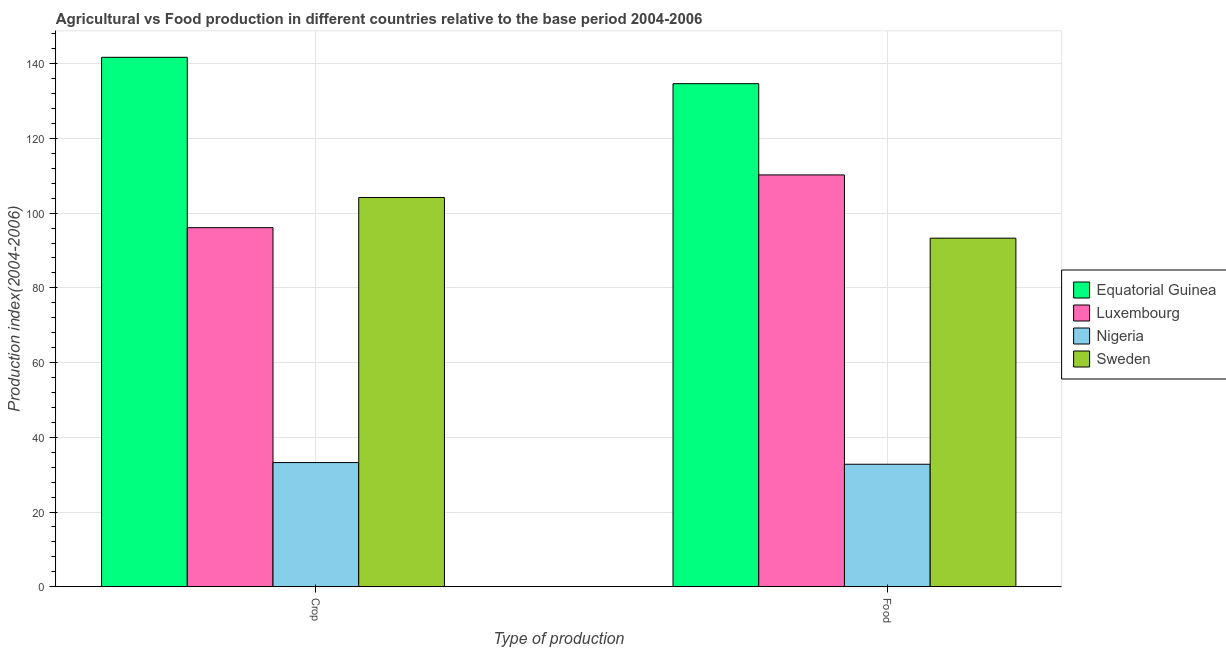Are the number of bars per tick equal to the number of legend labels?
Your response must be concise. Yes. Are the number of bars on each tick of the X-axis equal?
Provide a short and direct response. Yes. How many bars are there on the 2nd tick from the left?
Ensure brevity in your answer.  4. What is the label of the 1st group of bars from the left?
Provide a succinct answer. Crop. What is the crop production index in Sweden?
Your answer should be compact. 104.19. Across all countries, what is the maximum crop production index?
Keep it short and to the point. 141.71. Across all countries, what is the minimum food production index?
Your answer should be compact. 32.79. In which country was the food production index maximum?
Offer a very short reply. Equatorial Guinea. In which country was the crop production index minimum?
Offer a very short reply. Nigeria. What is the total crop production index in the graph?
Ensure brevity in your answer.  375.25. What is the difference between the crop production index in Luxembourg and that in Equatorial Guinea?
Provide a short and direct response. -45.6. What is the difference between the food production index in Luxembourg and the crop production index in Sweden?
Offer a very short reply. 6.04. What is the average food production index per country?
Keep it short and to the point. 92.74. What is the difference between the crop production index and food production index in Luxembourg?
Give a very brief answer. -14.12. What is the ratio of the food production index in Sweden to that in Nigeria?
Ensure brevity in your answer.  2.85. In how many countries, is the crop production index greater than the average crop production index taken over all countries?
Offer a terse response. 3. What does the 3rd bar from the left in Crop represents?
Ensure brevity in your answer.  Nigeria. What does the 2nd bar from the right in Food represents?
Give a very brief answer. Nigeria. Are all the bars in the graph horizontal?
Offer a terse response. No. How many countries are there in the graph?
Ensure brevity in your answer.  4. Does the graph contain any zero values?
Keep it short and to the point. No. How are the legend labels stacked?
Provide a short and direct response. Vertical. What is the title of the graph?
Provide a short and direct response. Agricultural vs Food production in different countries relative to the base period 2004-2006. Does "Congo (Democratic)" appear as one of the legend labels in the graph?
Keep it short and to the point. No. What is the label or title of the X-axis?
Your response must be concise. Type of production. What is the label or title of the Y-axis?
Make the answer very short. Production index(2004-2006). What is the Production index(2004-2006) of Equatorial Guinea in Crop?
Provide a succinct answer. 141.71. What is the Production index(2004-2006) in Luxembourg in Crop?
Offer a very short reply. 96.11. What is the Production index(2004-2006) of Nigeria in Crop?
Offer a very short reply. 33.24. What is the Production index(2004-2006) in Sweden in Crop?
Offer a terse response. 104.19. What is the Production index(2004-2006) of Equatorial Guinea in Food?
Offer a terse response. 134.65. What is the Production index(2004-2006) of Luxembourg in Food?
Your response must be concise. 110.23. What is the Production index(2004-2006) in Nigeria in Food?
Make the answer very short. 32.79. What is the Production index(2004-2006) of Sweden in Food?
Offer a very short reply. 93.3. Across all Type of production, what is the maximum Production index(2004-2006) in Equatorial Guinea?
Keep it short and to the point. 141.71. Across all Type of production, what is the maximum Production index(2004-2006) of Luxembourg?
Offer a very short reply. 110.23. Across all Type of production, what is the maximum Production index(2004-2006) in Nigeria?
Your answer should be compact. 33.24. Across all Type of production, what is the maximum Production index(2004-2006) of Sweden?
Offer a very short reply. 104.19. Across all Type of production, what is the minimum Production index(2004-2006) in Equatorial Guinea?
Give a very brief answer. 134.65. Across all Type of production, what is the minimum Production index(2004-2006) of Luxembourg?
Give a very brief answer. 96.11. Across all Type of production, what is the minimum Production index(2004-2006) in Nigeria?
Make the answer very short. 32.79. Across all Type of production, what is the minimum Production index(2004-2006) of Sweden?
Make the answer very short. 93.3. What is the total Production index(2004-2006) of Equatorial Guinea in the graph?
Give a very brief answer. 276.36. What is the total Production index(2004-2006) in Luxembourg in the graph?
Make the answer very short. 206.34. What is the total Production index(2004-2006) of Nigeria in the graph?
Make the answer very short. 66.03. What is the total Production index(2004-2006) in Sweden in the graph?
Offer a very short reply. 197.49. What is the difference between the Production index(2004-2006) in Equatorial Guinea in Crop and that in Food?
Keep it short and to the point. 7.06. What is the difference between the Production index(2004-2006) in Luxembourg in Crop and that in Food?
Offer a very short reply. -14.12. What is the difference between the Production index(2004-2006) of Nigeria in Crop and that in Food?
Make the answer very short. 0.45. What is the difference between the Production index(2004-2006) in Sweden in Crop and that in Food?
Keep it short and to the point. 10.89. What is the difference between the Production index(2004-2006) of Equatorial Guinea in Crop and the Production index(2004-2006) of Luxembourg in Food?
Offer a terse response. 31.48. What is the difference between the Production index(2004-2006) of Equatorial Guinea in Crop and the Production index(2004-2006) of Nigeria in Food?
Offer a very short reply. 108.92. What is the difference between the Production index(2004-2006) of Equatorial Guinea in Crop and the Production index(2004-2006) of Sweden in Food?
Offer a terse response. 48.41. What is the difference between the Production index(2004-2006) in Luxembourg in Crop and the Production index(2004-2006) in Nigeria in Food?
Give a very brief answer. 63.32. What is the difference between the Production index(2004-2006) in Luxembourg in Crop and the Production index(2004-2006) in Sweden in Food?
Offer a terse response. 2.81. What is the difference between the Production index(2004-2006) of Nigeria in Crop and the Production index(2004-2006) of Sweden in Food?
Ensure brevity in your answer.  -60.06. What is the average Production index(2004-2006) of Equatorial Guinea per Type of production?
Offer a terse response. 138.18. What is the average Production index(2004-2006) in Luxembourg per Type of production?
Your answer should be very brief. 103.17. What is the average Production index(2004-2006) of Nigeria per Type of production?
Your answer should be very brief. 33.02. What is the average Production index(2004-2006) in Sweden per Type of production?
Provide a succinct answer. 98.75. What is the difference between the Production index(2004-2006) in Equatorial Guinea and Production index(2004-2006) in Luxembourg in Crop?
Keep it short and to the point. 45.6. What is the difference between the Production index(2004-2006) in Equatorial Guinea and Production index(2004-2006) in Nigeria in Crop?
Keep it short and to the point. 108.47. What is the difference between the Production index(2004-2006) in Equatorial Guinea and Production index(2004-2006) in Sweden in Crop?
Give a very brief answer. 37.52. What is the difference between the Production index(2004-2006) in Luxembourg and Production index(2004-2006) in Nigeria in Crop?
Provide a succinct answer. 62.87. What is the difference between the Production index(2004-2006) of Luxembourg and Production index(2004-2006) of Sweden in Crop?
Provide a succinct answer. -8.08. What is the difference between the Production index(2004-2006) in Nigeria and Production index(2004-2006) in Sweden in Crop?
Your answer should be very brief. -70.95. What is the difference between the Production index(2004-2006) in Equatorial Guinea and Production index(2004-2006) in Luxembourg in Food?
Provide a short and direct response. 24.42. What is the difference between the Production index(2004-2006) in Equatorial Guinea and Production index(2004-2006) in Nigeria in Food?
Provide a short and direct response. 101.86. What is the difference between the Production index(2004-2006) in Equatorial Guinea and Production index(2004-2006) in Sweden in Food?
Provide a short and direct response. 41.35. What is the difference between the Production index(2004-2006) of Luxembourg and Production index(2004-2006) of Nigeria in Food?
Your answer should be compact. 77.44. What is the difference between the Production index(2004-2006) in Luxembourg and Production index(2004-2006) in Sweden in Food?
Provide a succinct answer. 16.93. What is the difference between the Production index(2004-2006) in Nigeria and Production index(2004-2006) in Sweden in Food?
Offer a very short reply. -60.51. What is the ratio of the Production index(2004-2006) of Equatorial Guinea in Crop to that in Food?
Provide a short and direct response. 1.05. What is the ratio of the Production index(2004-2006) in Luxembourg in Crop to that in Food?
Your answer should be very brief. 0.87. What is the ratio of the Production index(2004-2006) in Nigeria in Crop to that in Food?
Offer a terse response. 1.01. What is the ratio of the Production index(2004-2006) in Sweden in Crop to that in Food?
Your answer should be very brief. 1.12. What is the difference between the highest and the second highest Production index(2004-2006) of Equatorial Guinea?
Your answer should be compact. 7.06. What is the difference between the highest and the second highest Production index(2004-2006) of Luxembourg?
Provide a succinct answer. 14.12. What is the difference between the highest and the second highest Production index(2004-2006) of Nigeria?
Your answer should be very brief. 0.45. What is the difference between the highest and the second highest Production index(2004-2006) in Sweden?
Provide a succinct answer. 10.89. What is the difference between the highest and the lowest Production index(2004-2006) of Equatorial Guinea?
Provide a succinct answer. 7.06. What is the difference between the highest and the lowest Production index(2004-2006) in Luxembourg?
Your response must be concise. 14.12. What is the difference between the highest and the lowest Production index(2004-2006) of Nigeria?
Provide a short and direct response. 0.45. What is the difference between the highest and the lowest Production index(2004-2006) in Sweden?
Provide a short and direct response. 10.89. 